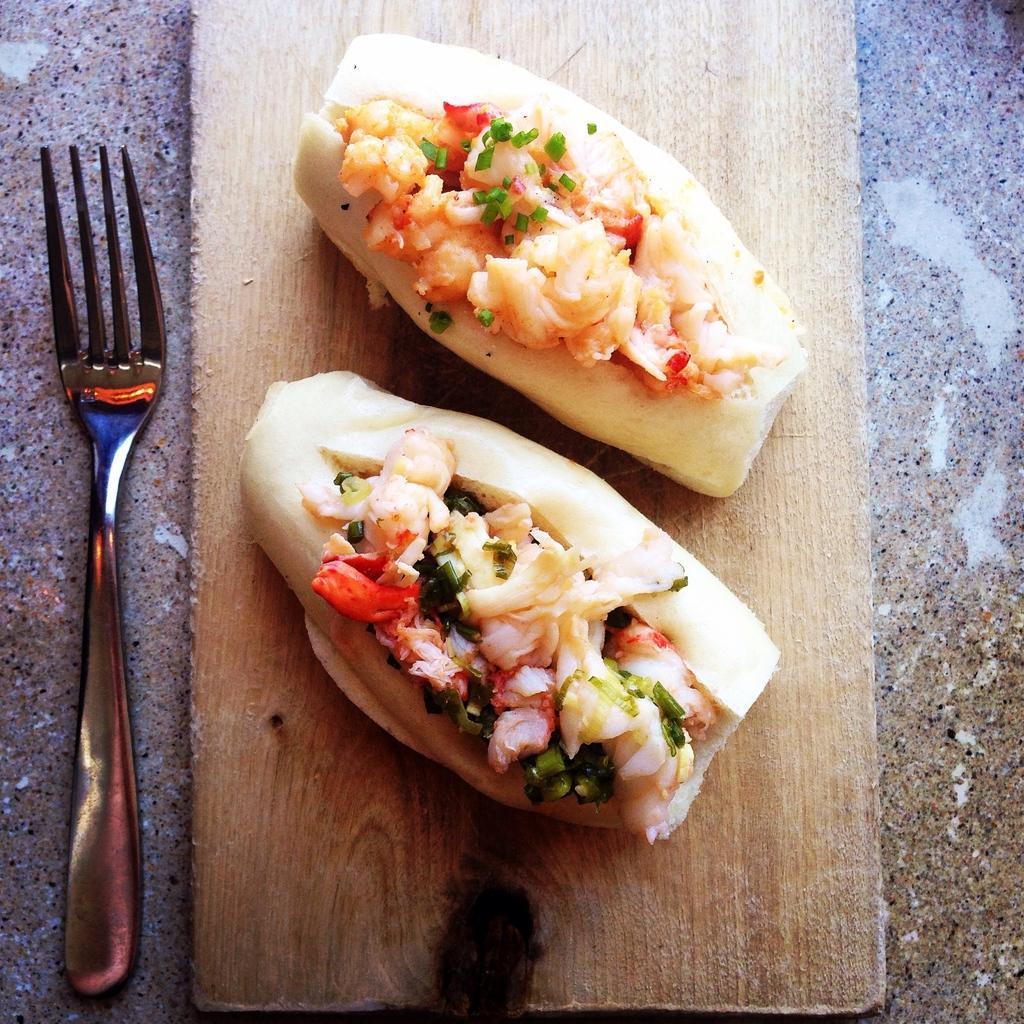Describe this image in one or two sentences. In this image we can see two food items on the wooden board, there is a fork, which are on the granite. 